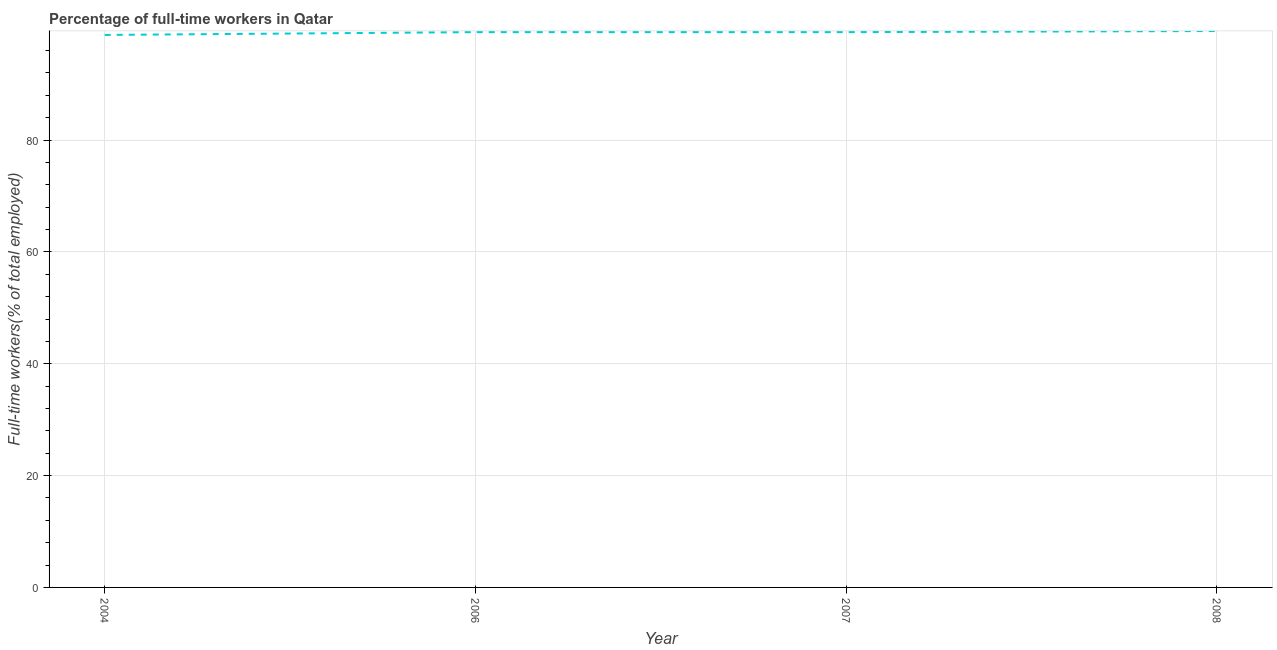What is the percentage of full-time workers in 2008?
Your answer should be very brief. 99.5. Across all years, what is the maximum percentage of full-time workers?
Provide a short and direct response. 99.5. Across all years, what is the minimum percentage of full-time workers?
Offer a terse response. 98.8. In which year was the percentage of full-time workers maximum?
Offer a very short reply. 2008. In which year was the percentage of full-time workers minimum?
Give a very brief answer. 2004. What is the sum of the percentage of full-time workers?
Your response must be concise. 396.9. What is the difference between the percentage of full-time workers in 2007 and 2008?
Your response must be concise. -0.2. What is the average percentage of full-time workers per year?
Your response must be concise. 99.23. What is the median percentage of full-time workers?
Offer a very short reply. 99.3. Do a majority of the years between 2006 and 2004 (inclusive) have percentage of full-time workers greater than 16 %?
Ensure brevity in your answer.  No. What is the ratio of the percentage of full-time workers in 2004 to that in 2007?
Your response must be concise. 0.99. Is the percentage of full-time workers in 2004 less than that in 2006?
Provide a succinct answer. Yes. Is the difference between the percentage of full-time workers in 2004 and 2006 greater than the difference between any two years?
Offer a terse response. No. What is the difference between the highest and the second highest percentage of full-time workers?
Your answer should be compact. 0.2. Is the sum of the percentage of full-time workers in 2004 and 2008 greater than the maximum percentage of full-time workers across all years?
Make the answer very short. Yes. What is the difference between the highest and the lowest percentage of full-time workers?
Offer a very short reply. 0.7. In how many years, is the percentage of full-time workers greater than the average percentage of full-time workers taken over all years?
Give a very brief answer. 3. Does the graph contain grids?
Your answer should be very brief. Yes. What is the title of the graph?
Offer a very short reply. Percentage of full-time workers in Qatar. What is the label or title of the X-axis?
Your answer should be compact. Year. What is the label or title of the Y-axis?
Give a very brief answer. Full-time workers(% of total employed). What is the Full-time workers(% of total employed) of 2004?
Keep it short and to the point. 98.8. What is the Full-time workers(% of total employed) of 2006?
Offer a very short reply. 99.3. What is the Full-time workers(% of total employed) in 2007?
Provide a short and direct response. 99.3. What is the Full-time workers(% of total employed) in 2008?
Your answer should be compact. 99.5. What is the difference between the Full-time workers(% of total employed) in 2004 and 2008?
Keep it short and to the point. -0.7. What is the difference between the Full-time workers(% of total employed) in 2006 and 2007?
Keep it short and to the point. 0. What is the difference between the Full-time workers(% of total employed) in 2006 and 2008?
Offer a terse response. -0.2. What is the ratio of the Full-time workers(% of total employed) in 2006 to that in 2007?
Your answer should be very brief. 1. What is the ratio of the Full-time workers(% of total employed) in 2006 to that in 2008?
Give a very brief answer. 1. 